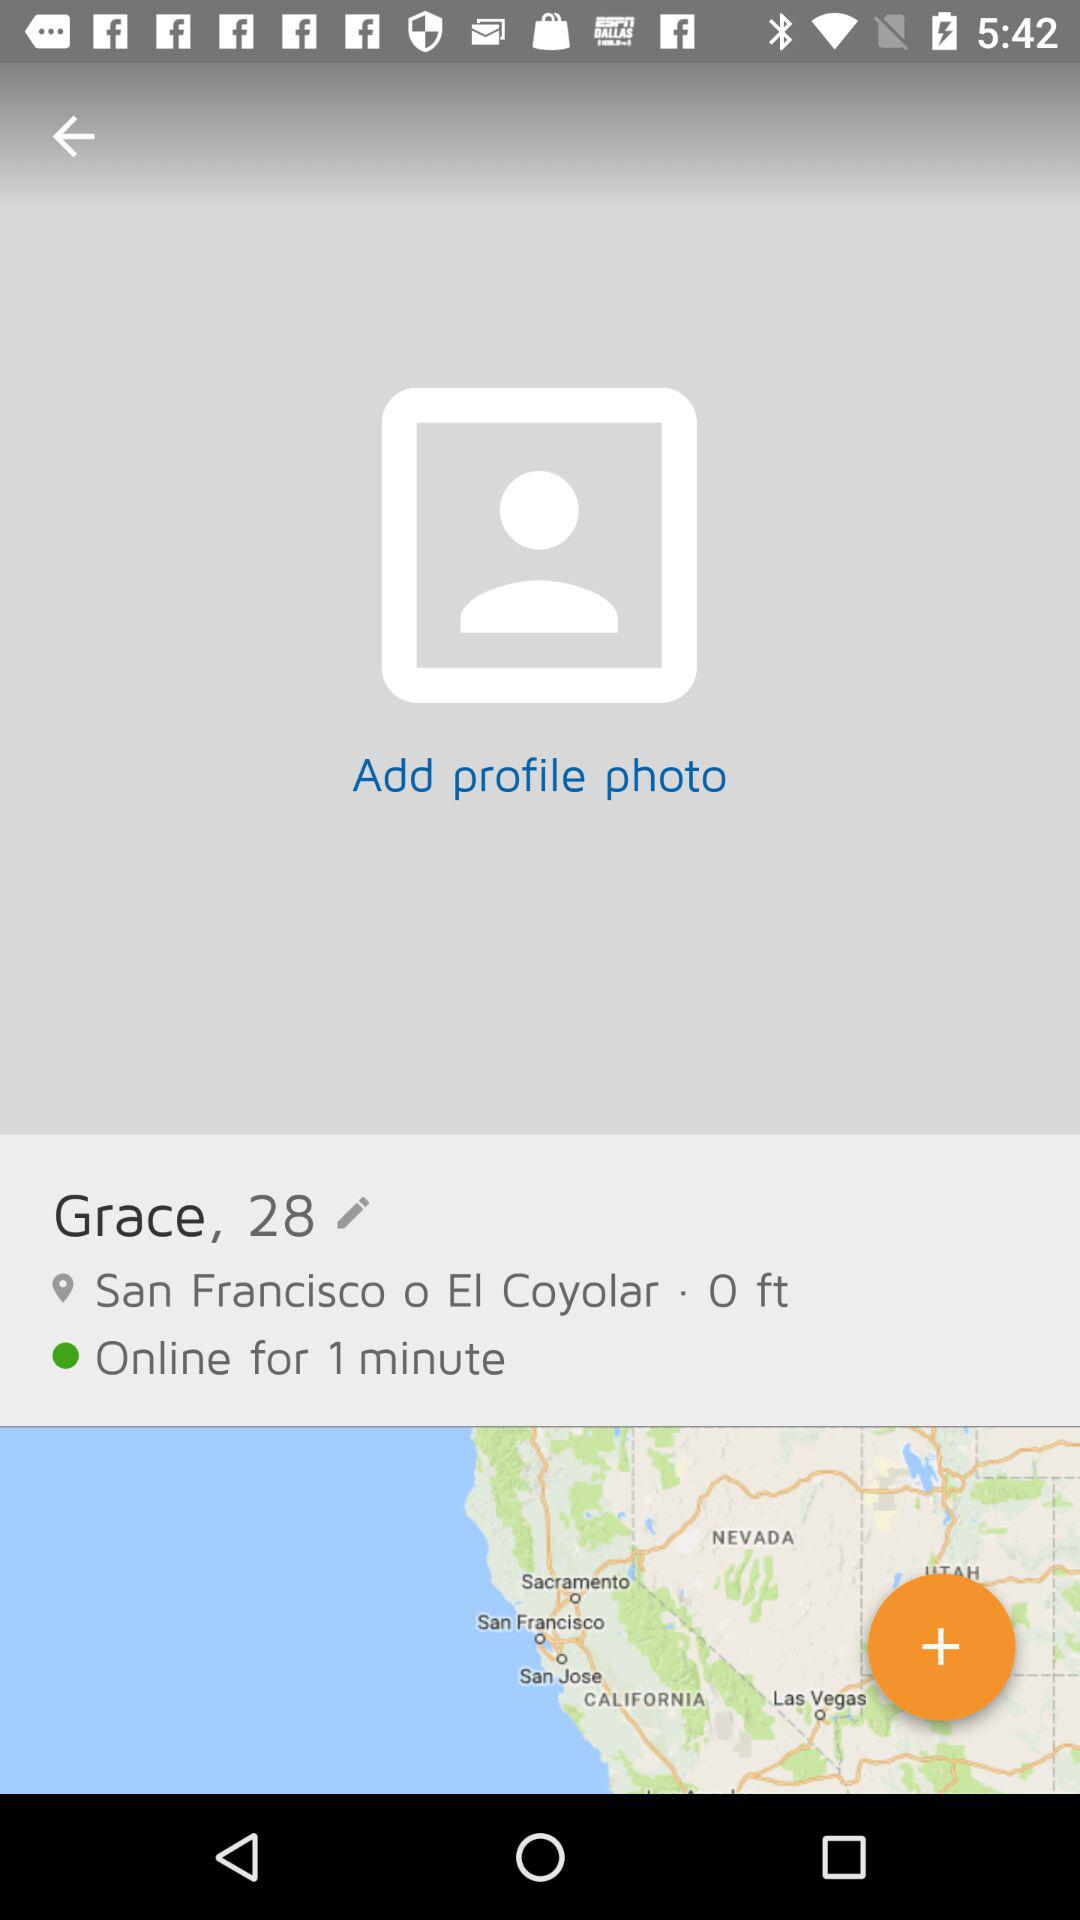What is the age? The age is 28 years. 